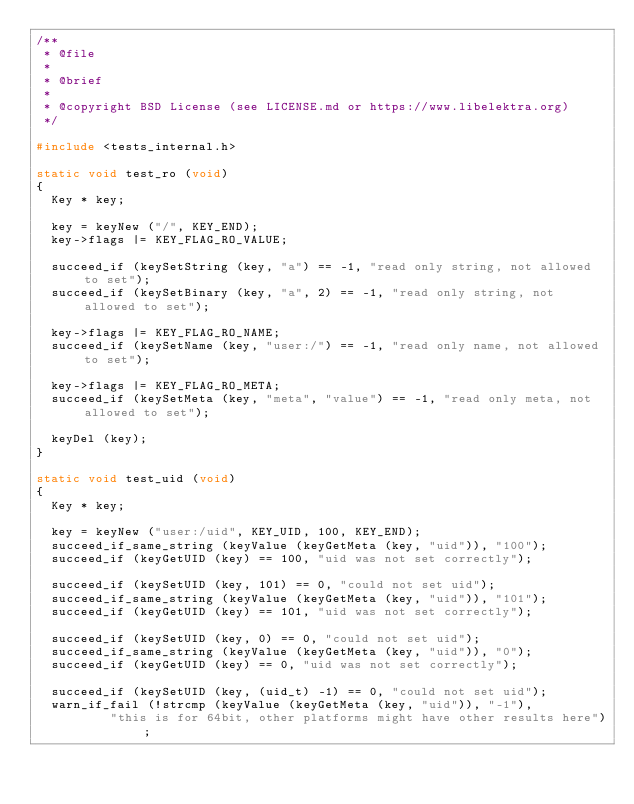Convert code to text. <code><loc_0><loc_0><loc_500><loc_500><_C_>/**
 * @file
 *
 * @brief
 *
 * @copyright BSD License (see LICENSE.md or https://www.libelektra.org)
 */

#include <tests_internal.h>

static void test_ro (void)
{
	Key * key;

	key = keyNew ("/", KEY_END);
	key->flags |= KEY_FLAG_RO_VALUE;

	succeed_if (keySetString (key, "a") == -1, "read only string, not allowed to set");
	succeed_if (keySetBinary (key, "a", 2) == -1, "read only string, not allowed to set");

	key->flags |= KEY_FLAG_RO_NAME;
	succeed_if (keySetName (key, "user:/") == -1, "read only name, not allowed to set");

	key->flags |= KEY_FLAG_RO_META;
	succeed_if (keySetMeta (key, "meta", "value") == -1, "read only meta, not allowed to set");

	keyDel (key);
}

static void test_uid (void)
{
	Key * key;

	key = keyNew ("user:/uid", KEY_UID, 100, KEY_END);
	succeed_if_same_string (keyValue (keyGetMeta (key, "uid")), "100");
	succeed_if (keyGetUID (key) == 100, "uid was not set correctly");

	succeed_if (keySetUID (key, 101) == 0, "could not set uid");
	succeed_if_same_string (keyValue (keyGetMeta (key, "uid")), "101");
	succeed_if (keyGetUID (key) == 101, "uid was not set correctly");

	succeed_if (keySetUID (key, 0) == 0, "could not set uid");
	succeed_if_same_string (keyValue (keyGetMeta (key, "uid")), "0");
	succeed_if (keyGetUID (key) == 0, "uid was not set correctly");

	succeed_if (keySetUID (key, (uid_t) -1) == 0, "could not set uid");
	warn_if_fail (!strcmp (keyValue (keyGetMeta (key, "uid")), "-1"),
		      "this is for 64bit, other platforms might have other results here");</code> 